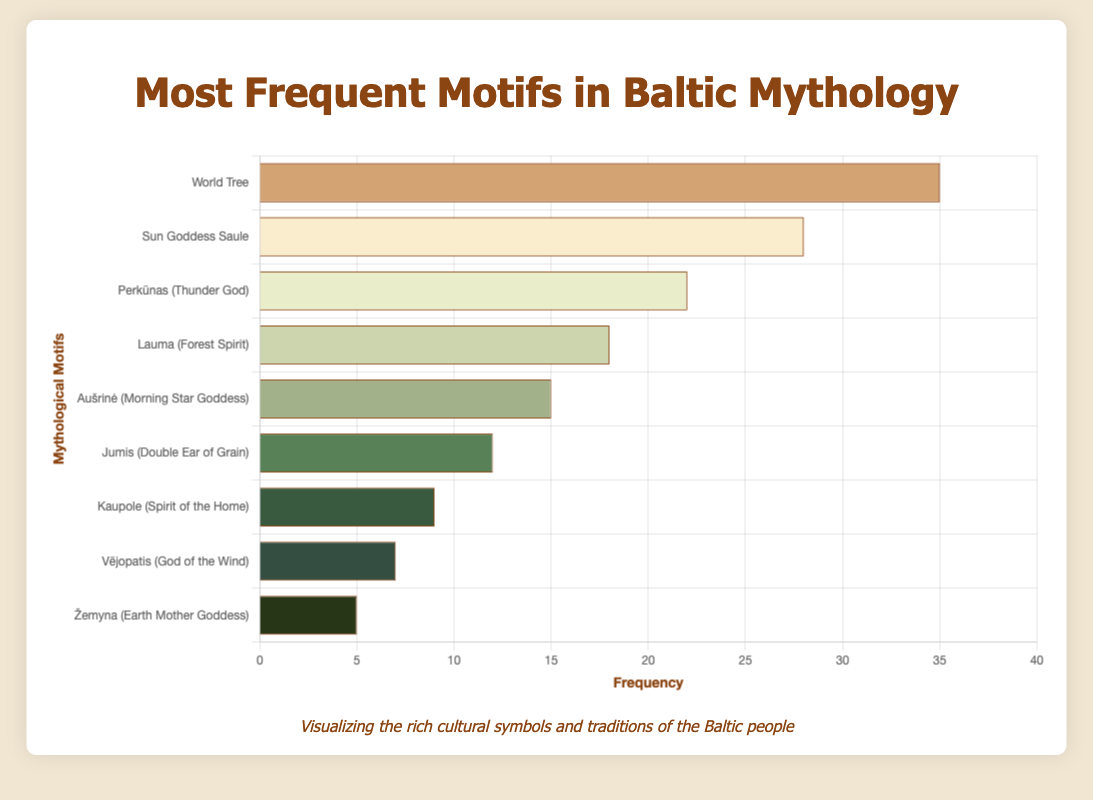Which mythological motif has the highest frequency? The motif with the highest frequency is represented by the tallest bar in the chart. The "World Tree" has the highest frequency of 35.
Answer: World Tree How many more times does the "Sun Goddess Saule" appear compared to "Žemyna (Earth Mother Goddess)"? The frequency of "Sun Goddess Saule" is 28 and the frequency of "Žemyna (Earth Mother Goddess)" is 5. The difference is 28 - 5 = 23.
Answer: 23 Which motifs have a frequency greater than 20 and what are their names? The motifs with frequencies greater than 20 are represented by bars that extend past the 20 mark on the x-axis. These are "World Tree" (35), "Sun Goddess Saule" (28), and "Perkūnas (Thunder God)" (22).
Answer: World Tree, Sun Goddess Saule, Perkūnas (Thunder God) What is the rank of "Lauma (Forest Spirit)" in terms of frequency? To find the rank, we order the motifs by frequency: 35 (World Tree), 28 (Sun Goddess Saule), 22 (Perkūnas), 18 (Lauma). "Lauma (Forest Spirit)" is 4th in the list.
Answer: 4th What is the total frequency of all motifs combined? Add up all the individual frequencies: 35 (World Tree) + 28 (Sun Goddess Saule) + 22 (Perkūnas) + 18 (Lauma) + 15 (Aušrinė) + 12 (Jumis) + 9 (Kaupole) + 7 (Vējopatis) + 5 (Žemyna) = 151.
Answer: 151 How does the frequency of "Perkūnas (Thunder God)" compare to "Aušrinė (Morning Star Goddess)"? The frequency of "Perkūnas" is 22 and the frequency of "Aušrinė" is 15. Comparing them, 22 is greater than 15.
Answer: Perkūnas is greater Which motif has the smallest frequency and what is its value? The motif with the smallest frequency is represented by the shortest bar in the chart. "Žemyna (Earth Mother Goddess)" has a frequency of 5.
Answer: Žemyna, 5 What is the average frequency of the motifs? The average frequency is calculated by dividing the total frequency by the number of motifs: Total frequency is 151 and there are 9 motifs. 151 / 9 = 16.78 (rounded to 2 decimal places).
Answer: 16.78 What is the difference between the highest and lowest frequencies? The highest frequency is 35 (World Tree) and the lowest frequency is 5 (Žemyna). The difference is 35 - 5 = 30.
Answer: 30 